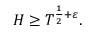Convert formula to latex. <formula><loc_0><loc_0><loc_500><loc_500>H \geq T ^ { { \frac { 1 } { 2 } } + \varepsilon } .</formula> 